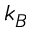Convert formula to latex. <formula><loc_0><loc_0><loc_500><loc_500>k _ { B }</formula> 